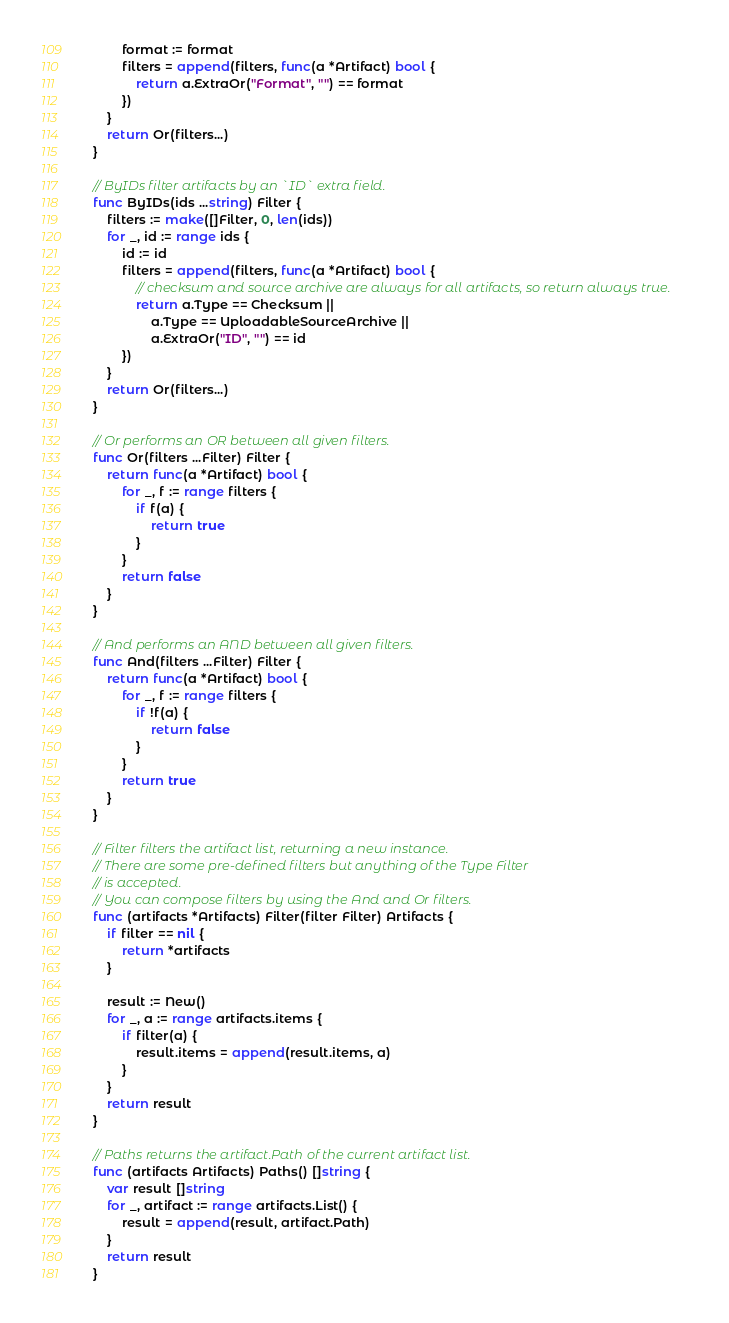<code> <loc_0><loc_0><loc_500><loc_500><_Go_>		format := format
		filters = append(filters, func(a *Artifact) bool {
			return a.ExtraOr("Format", "") == format
		})
	}
	return Or(filters...)
}

// ByIDs filter artifacts by an `ID` extra field.
func ByIDs(ids ...string) Filter {
	filters := make([]Filter, 0, len(ids))
	for _, id := range ids {
		id := id
		filters = append(filters, func(a *Artifact) bool {
			// checksum and source archive are always for all artifacts, so return always true.
			return a.Type == Checksum ||
				a.Type == UploadableSourceArchive ||
				a.ExtraOr("ID", "") == id
		})
	}
	return Or(filters...)
}

// Or performs an OR between all given filters.
func Or(filters ...Filter) Filter {
	return func(a *Artifact) bool {
		for _, f := range filters {
			if f(a) {
				return true
			}
		}
		return false
	}
}

// And performs an AND between all given filters.
func And(filters ...Filter) Filter {
	return func(a *Artifact) bool {
		for _, f := range filters {
			if !f(a) {
				return false
			}
		}
		return true
	}
}

// Filter filters the artifact list, returning a new instance.
// There are some pre-defined filters but anything of the Type Filter
// is accepted.
// You can compose filters by using the And and Or filters.
func (artifacts *Artifacts) Filter(filter Filter) Artifacts {
	if filter == nil {
		return *artifacts
	}

	result := New()
	for _, a := range artifacts.items {
		if filter(a) {
			result.items = append(result.items, a)
		}
	}
	return result
}

// Paths returns the artifact.Path of the current artifact list.
func (artifacts Artifacts) Paths() []string {
	var result []string
	for _, artifact := range artifacts.List() {
		result = append(result, artifact.Path)
	}
	return result
}
</code> 